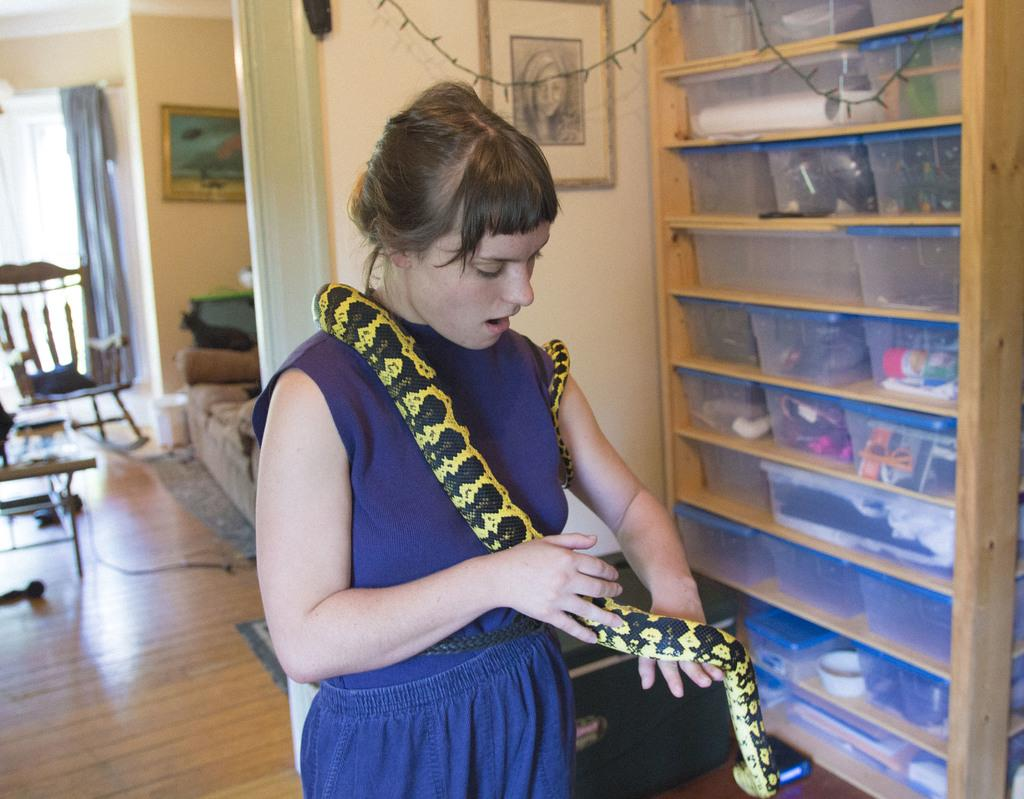What type of covering can be seen in the image? There is a curtain in the image. What is the background of the image made of? There is a wall in the image. What type of decorative item is present in the image? There is a photo frame in the image. What type of furniture is on the left side of the image? There are chairs on the left side of the image. What is the woman in the image holding? The woman is holding a snake in the image. What type of beam is visible in the image? There is no beam present in the image. What type of teeth can be seen in the image? There are no teeth visible in the image. 